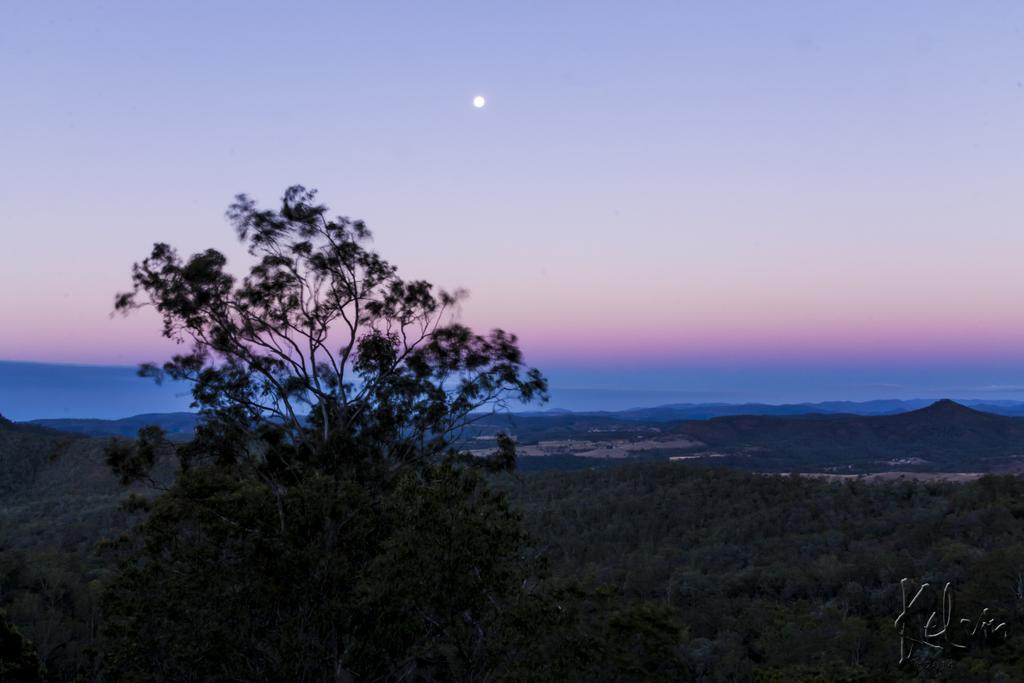What type of vegetation is present in the image? There is a tree and plants in the image. What can be seen in the background of the image? There are mountains and the sky visible in the background of the image. What celestial body is observable in the sky? The moon is observable in the sky. What type of stamp can be seen on the crow's wing in the image? There is no crow or stamp present in the image. What is the crow using the pail for in the image? There is no crow or pail present in the image. 